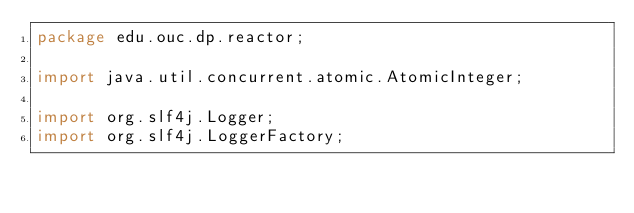<code> <loc_0><loc_0><loc_500><loc_500><_Java_>package edu.ouc.dp.reactor;

import java.util.concurrent.atomic.AtomicInteger;

import org.slf4j.Logger;
import org.slf4j.LoggerFactory;
</code> 